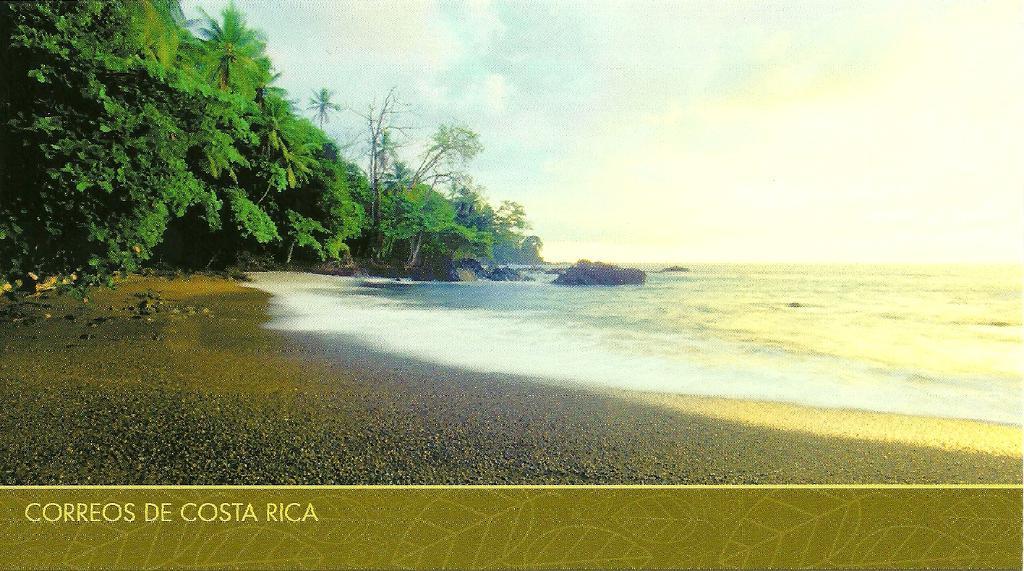How would you summarize this image in a sentence or two? In this image I can see the ground, few trees which are green in color, few huge rocks and the water. In the background I can see the sky. 